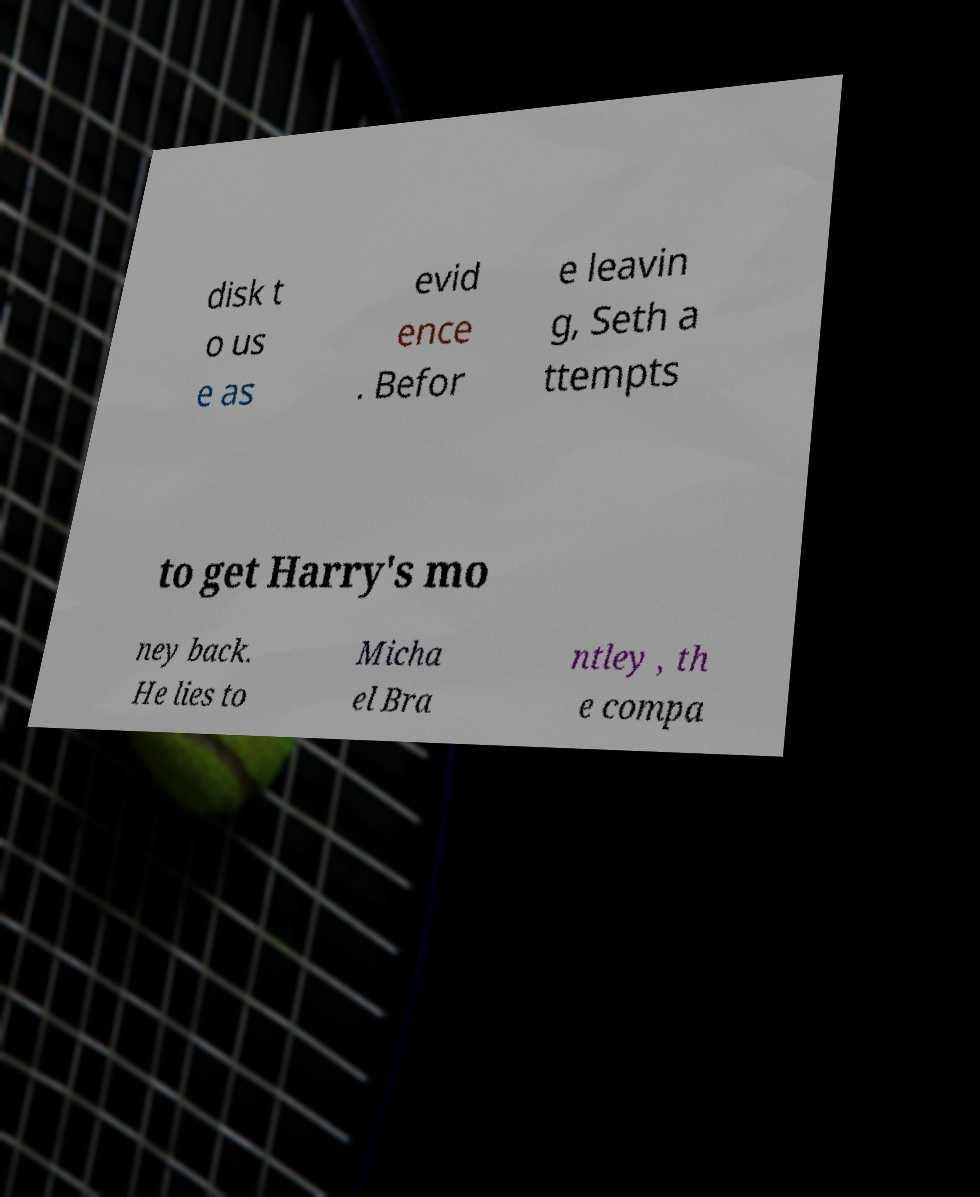Could you extract and type out the text from this image? disk t o us e as evid ence . Befor e leavin g, Seth a ttempts to get Harry's mo ney back. He lies to Micha el Bra ntley , th e compa 